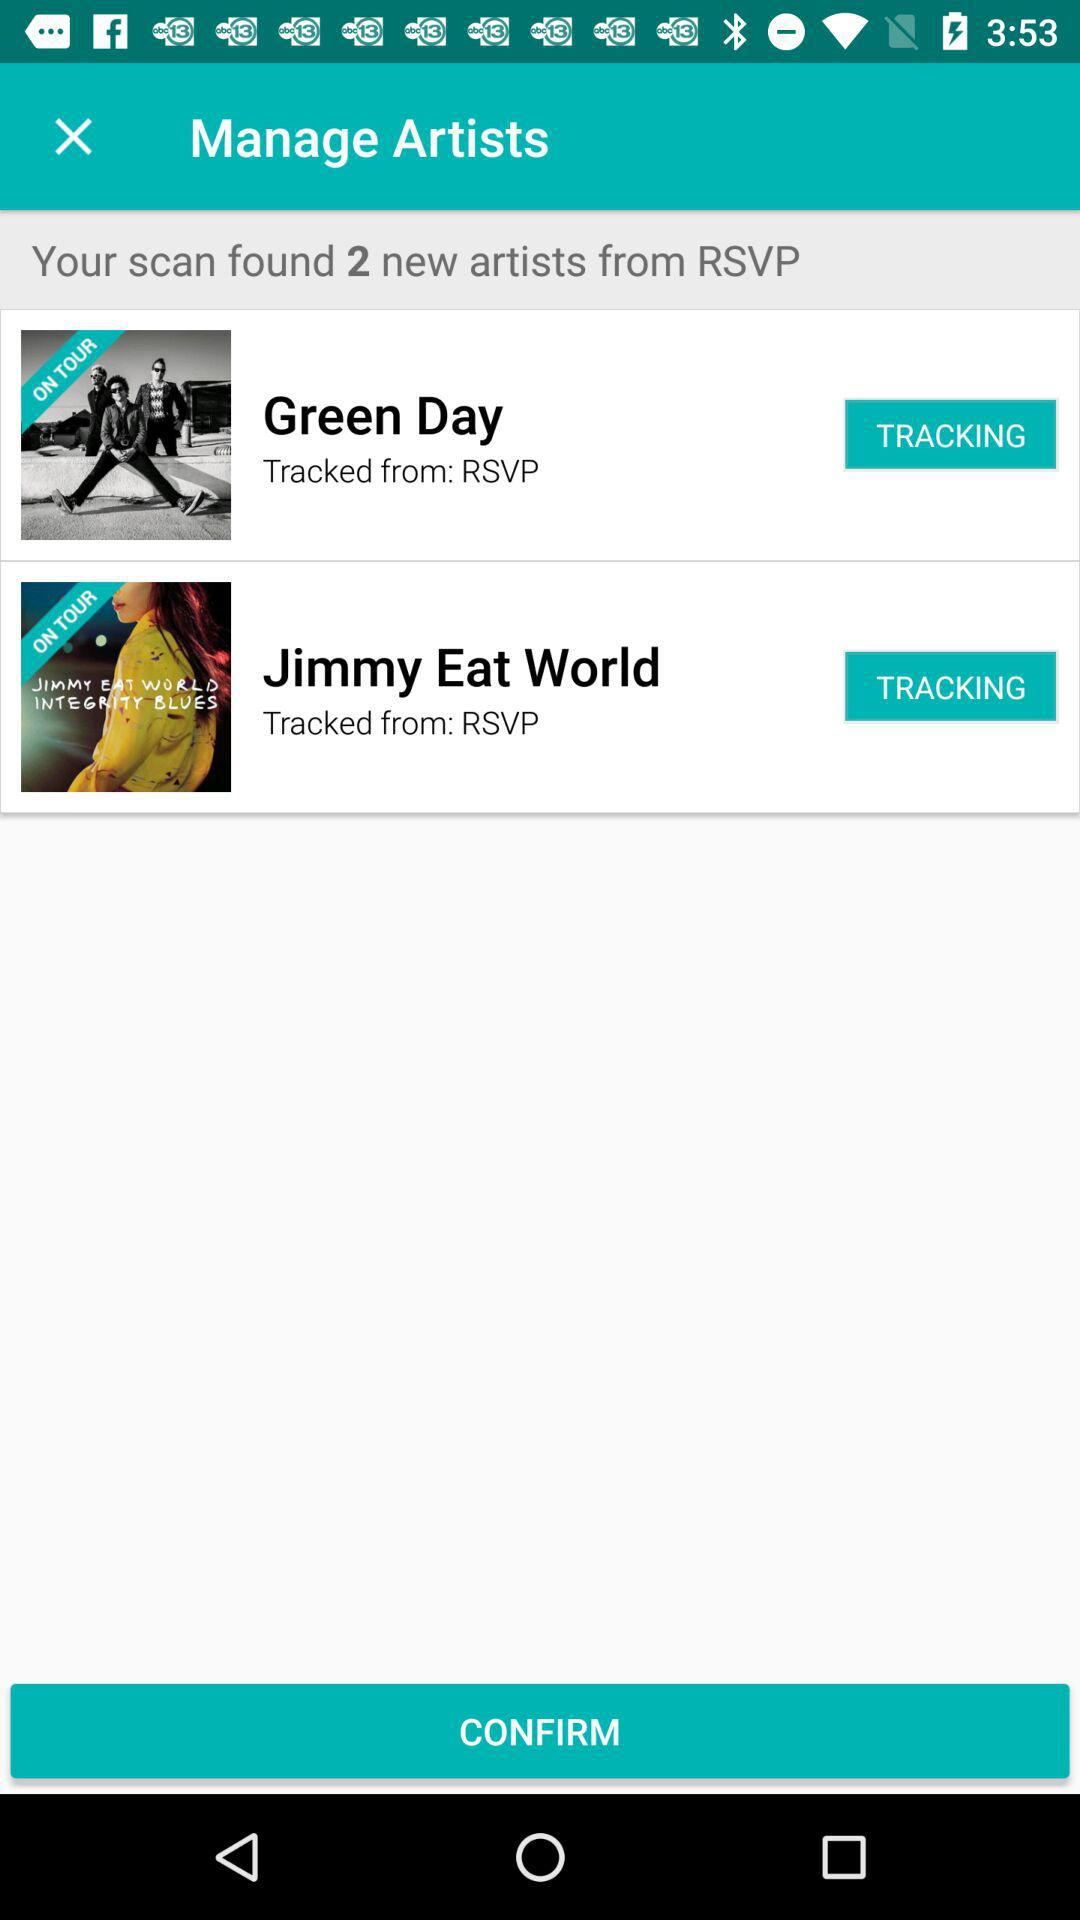Name the artists from RSVP? The artists are "Green Day" and "Jimmy Eat World". 